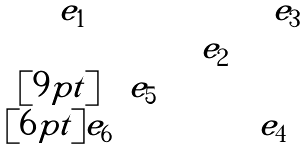Convert formula to latex. <formula><loc_0><loc_0><loc_500><loc_500>\begin{matrix} \quad e _ { 1 } & & & \quad e _ { 3 } \\ & & \quad e _ { 2 } & \\ [ 9 p t ] & e _ { 5 } & & \\ [ 6 p t ] e _ { 6 } & & & e _ { 4 } \end{matrix}</formula> 